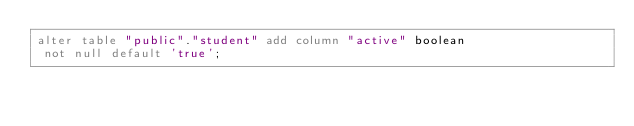Convert code to text. <code><loc_0><loc_0><loc_500><loc_500><_SQL_>alter table "public"."student" add column "active" boolean
 not null default 'true';
</code> 